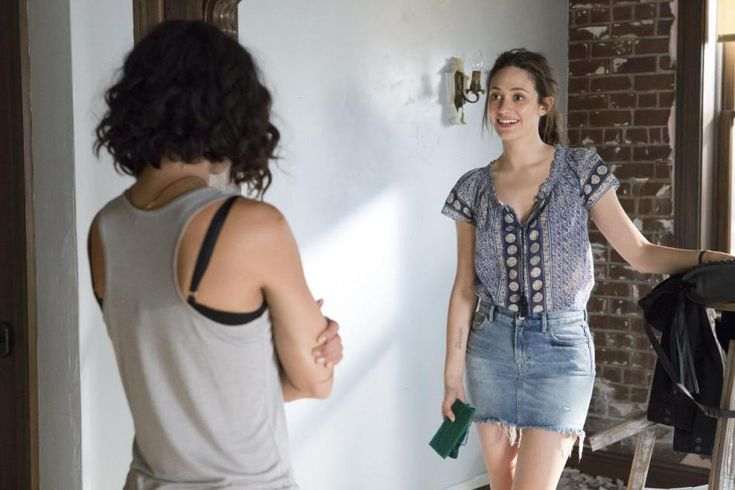Imagine a wild scenario where this image is part of a mystery story. What could be happening here? In an unexpected twist, the woman holding the green book has just uncovered a hidden message within its pages that could unravel an age-old mystery. The brick wall behind her hides a secret compartment where a crucial piece of evidence is stashed. The other woman, who seems to be just a casual acquaintance, is actually an undercover detective working to solve the sharegpt4v/same mystery. They are discussing the next steps to decode the message and find the hidden compartment, unaware that they are being watched by someone who wants to keep the mystery unsolved at all costs. 